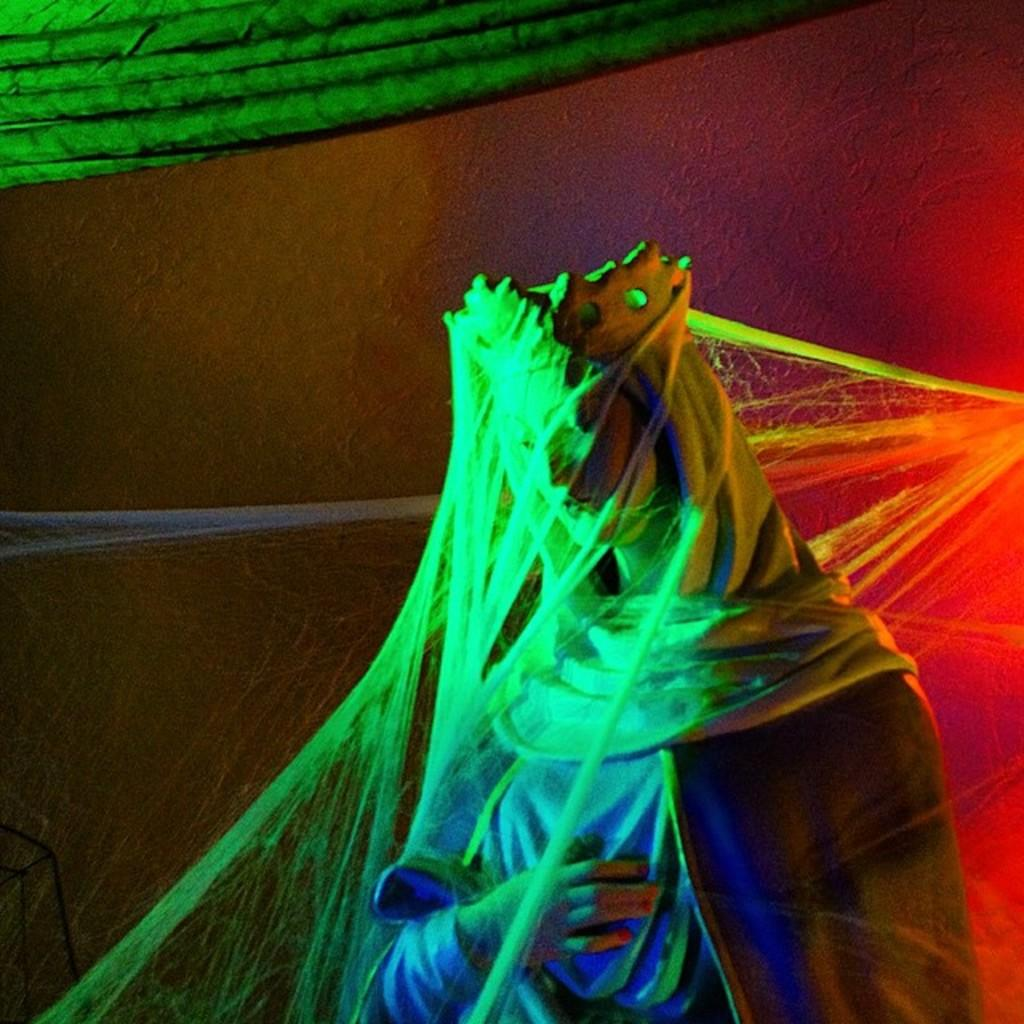What is the main subject of the image? There is a statue in the image. What is covering the statue? The statue is covered with web. What can be seen at the top of the image? There are green curtains at the top of the image. Can you describe the earthquake happening in the image? There is no earthquake depicted in the image; it features a statue covered with web and green curtains at the top. What type of tree can be seen growing near the statue in the image? There is no tree present in the image; it only shows a statue covered with web and green curtains at the top. 